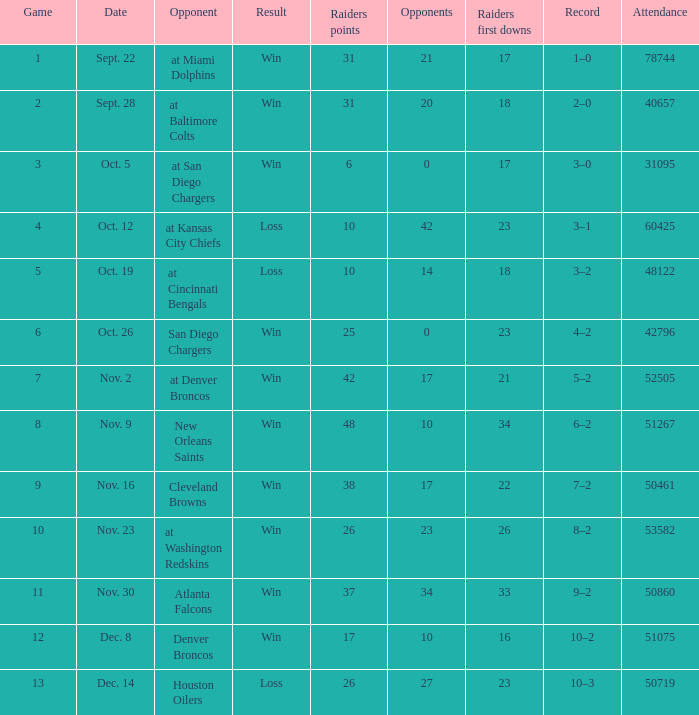Would you mind parsing the complete table? {'header': ['Game', 'Date', 'Opponent', 'Result', 'Raiders points', 'Opponents', 'Raiders first downs', 'Record', 'Attendance'], 'rows': [['1', 'Sept. 22', 'at Miami Dolphins', 'Win', '31', '21', '17', '1–0', '78744'], ['2', 'Sept. 28', 'at Baltimore Colts', 'Win', '31', '20', '18', '2–0', '40657'], ['3', 'Oct. 5', 'at San Diego Chargers', 'Win', '6', '0', '17', '3–0', '31095'], ['4', 'Oct. 12', 'at Kansas City Chiefs', 'Loss', '10', '42', '23', '3–1', '60425'], ['5', 'Oct. 19', 'at Cincinnati Bengals', 'Loss', '10', '14', '18', '3–2', '48122'], ['6', 'Oct. 26', 'San Diego Chargers', 'Win', '25', '0', '23', '4–2', '42796'], ['7', 'Nov. 2', 'at Denver Broncos', 'Win', '42', '17', '21', '5–2', '52505'], ['8', 'Nov. 9', 'New Orleans Saints', 'Win', '48', '10', '34', '6–2', '51267'], ['9', 'Nov. 16', 'Cleveland Browns', 'Win', '38', '17', '22', '7–2', '50461'], ['10', 'Nov. 23', 'at Washington Redskins', 'Win', '26', '23', '26', '8–2', '53582'], ['11', 'Nov. 30', 'Atlanta Falcons', 'Win', '37', '34', '33', '9–2', '50860'], ['12', 'Dec. 8', 'Denver Broncos', 'Win', '17', '10', '16', '10–2', '51075'], ['13', 'Dec. 14', 'Houston Oilers', 'Loss', '26', '27', '23', '10–3', '50719']]} For the game attended by 31,095 people, what was the end result? Win. 